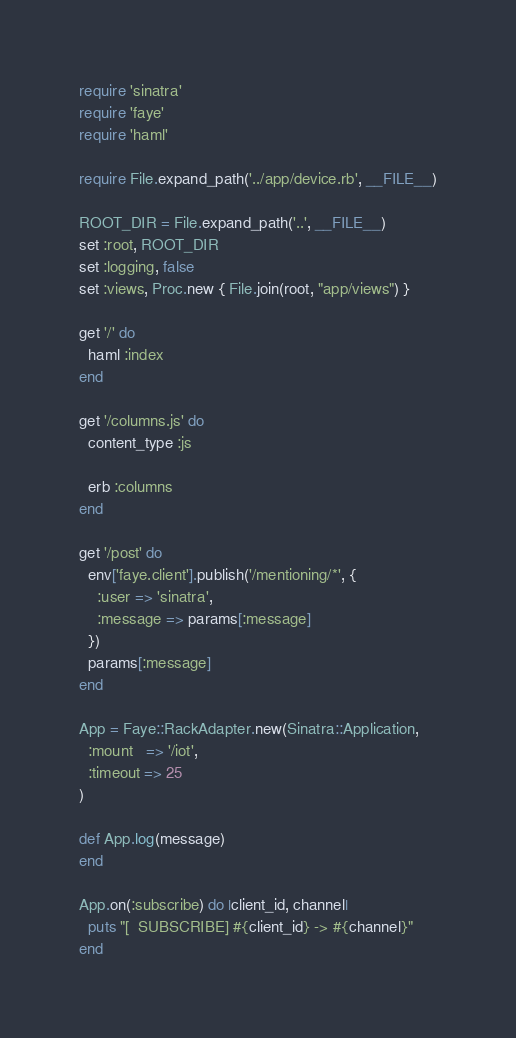Convert code to text. <code><loc_0><loc_0><loc_500><loc_500><_Ruby_>require 'sinatra'
require 'faye'
require 'haml'

require File.expand_path('../app/device.rb', __FILE__)

ROOT_DIR = File.expand_path('..', __FILE__)
set :root, ROOT_DIR
set :logging, false
set :views, Proc.new { File.join(root, "app/views") }

get '/' do
  haml :index
end

get '/columns.js' do
  content_type :js

  erb :columns
end

get '/post' do
  env['faye.client'].publish('/mentioning/*', {
    :user => 'sinatra',
    :message => params[:message]
  })
  params[:message]
end

App = Faye::RackAdapter.new(Sinatra::Application,
  :mount   => '/iot',
  :timeout => 25
)

def App.log(message)
end

App.on(:subscribe) do |client_id, channel|
  puts "[  SUBSCRIBE] #{client_id} -> #{channel}"
end
</code> 